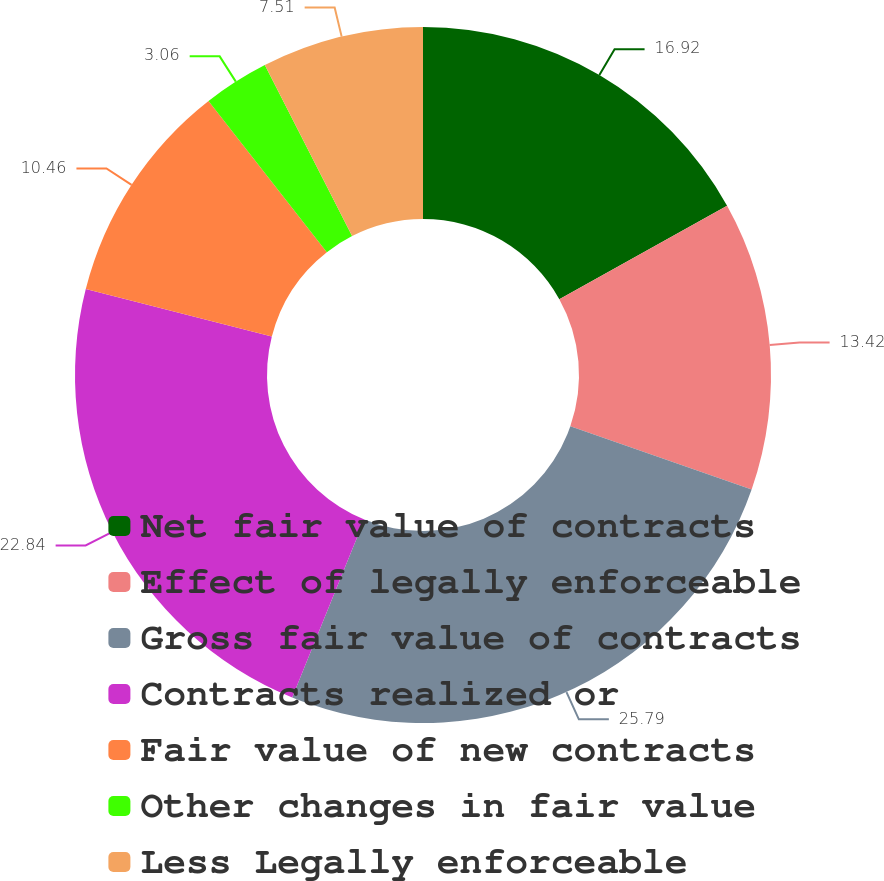<chart> <loc_0><loc_0><loc_500><loc_500><pie_chart><fcel>Net fair value of contracts<fcel>Effect of legally enforceable<fcel>Gross fair value of contracts<fcel>Contracts realized or<fcel>Fair value of new contracts<fcel>Other changes in fair value<fcel>Less Legally enforceable<nl><fcel>16.92%<fcel>13.42%<fcel>25.8%<fcel>22.84%<fcel>10.46%<fcel>3.06%<fcel>7.51%<nl></chart> 